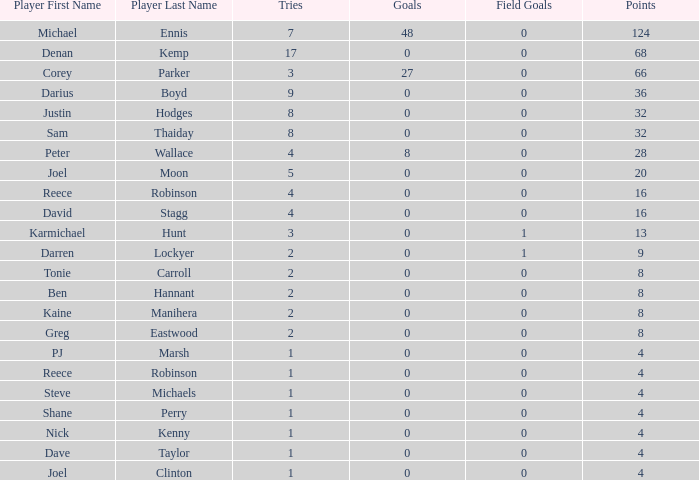How many points did the player with 2 tries and more than 0 field goals have? 9.0. 